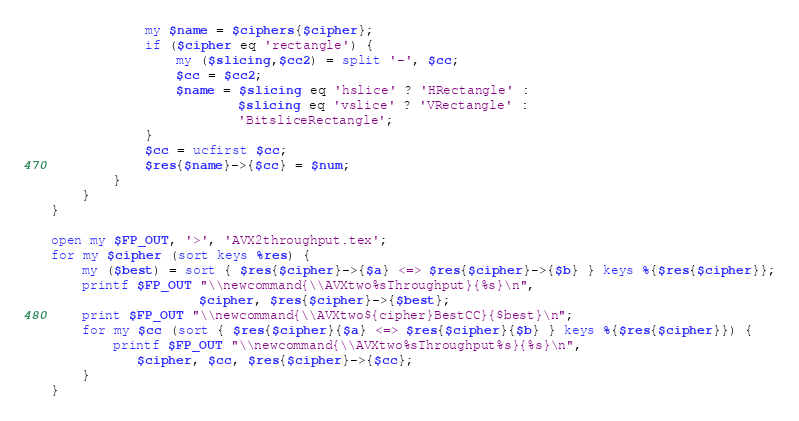<code> <loc_0><loc_0><loc_500><loc_500><_Perl_>            my $name = $ciphers{$cipher};
            if ($cipher eq 'rectangle') {
                my ($slicing,$cc2) = split '-', $cc;
                $cc = $cc2;
                $name = $slicing eq 'hslice' ? 'HRectangle' :
                        $slicing eq 'vslice' ? 'VRectangle' :
                        'BitsliceRectangle';
            }
            $cc = ucfirst $cc;
            $res{$name}->{$cc} = $num;
        }
    }
}

open my $FP_OUT, '>', 'AVX2throughput.tex';
for my $cipher (sort keys %res) {
    my ($best) = sort { $res{$cipher}->{$a} <=> $res{$cipher}->{$b} } keys %{$res{$cipher}};
    printf $FP_OUT "\\newcommand{\\AVXtwo%sThroughput}{%s}\n",
                   $cipher, $res{$cipher}->{$best};
    print $FP_OUT "\\newcommand{\\AVXtwo${cipher}BestCC}{$best}\n";
    for my $cc (sort { $res{$cipher}{$a} <=> $res{$cipher}{$b} } keys %{$res{$cipher}}) {
        printf $FP_OUT "\\newcommand{\\AVXtwo%sThroughput%s}{%s}\n",
           $cipher, $cc, $res{$cipher}->{$cc};
    }
}
</code> 